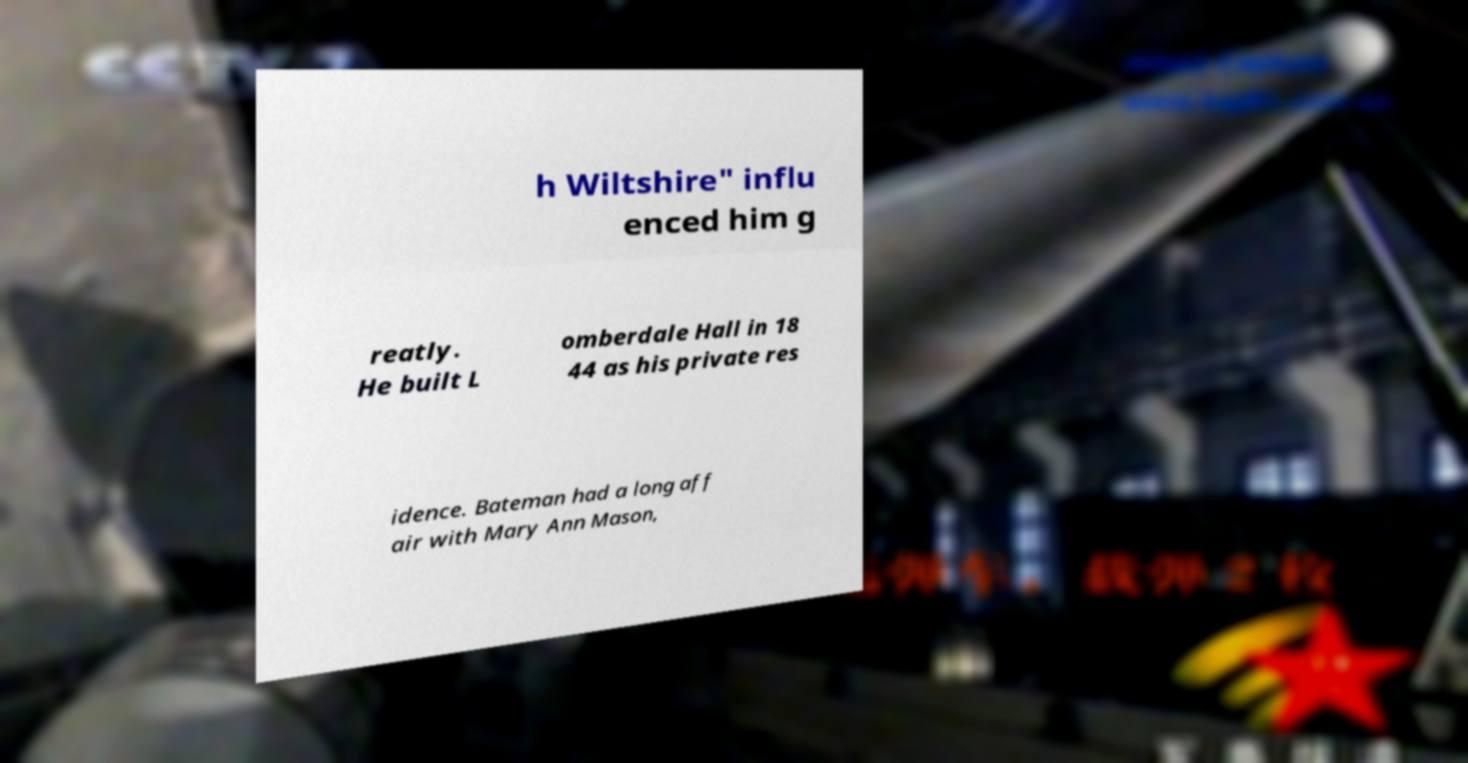Please read and relay the text visible in this image. What does it say? h Wiltshire" influ enced him g reatly. He built L omberdale Hall in 18 44 as his private res idence. Bateman had a long aff air with Mary Ann Mason, 